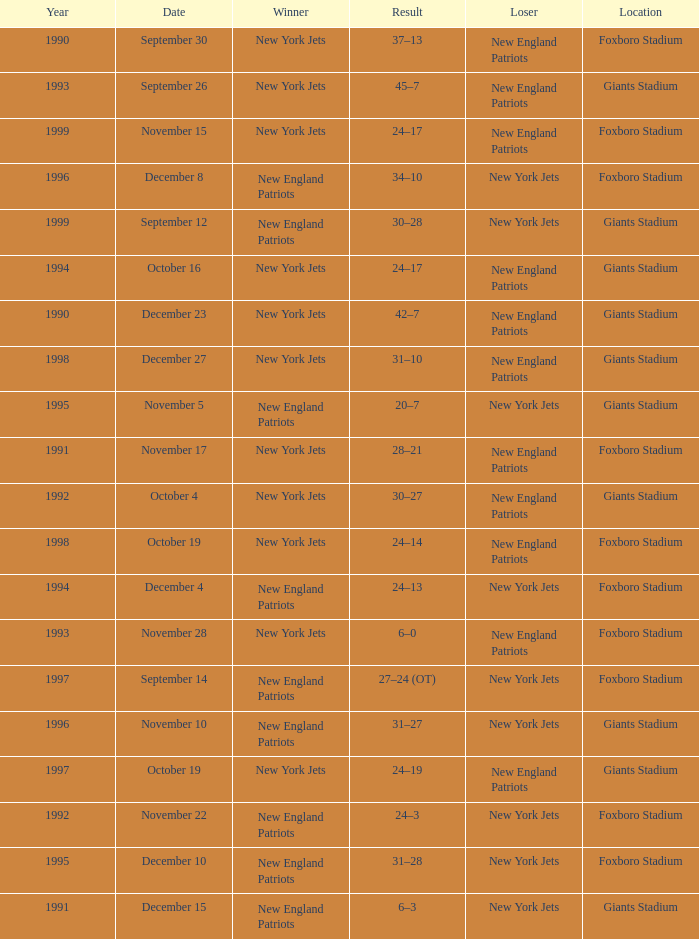What team was the lower when the winner was the new york jets, and a Year earlier than 1994, and a Result of 37–13? New England Patriots. 